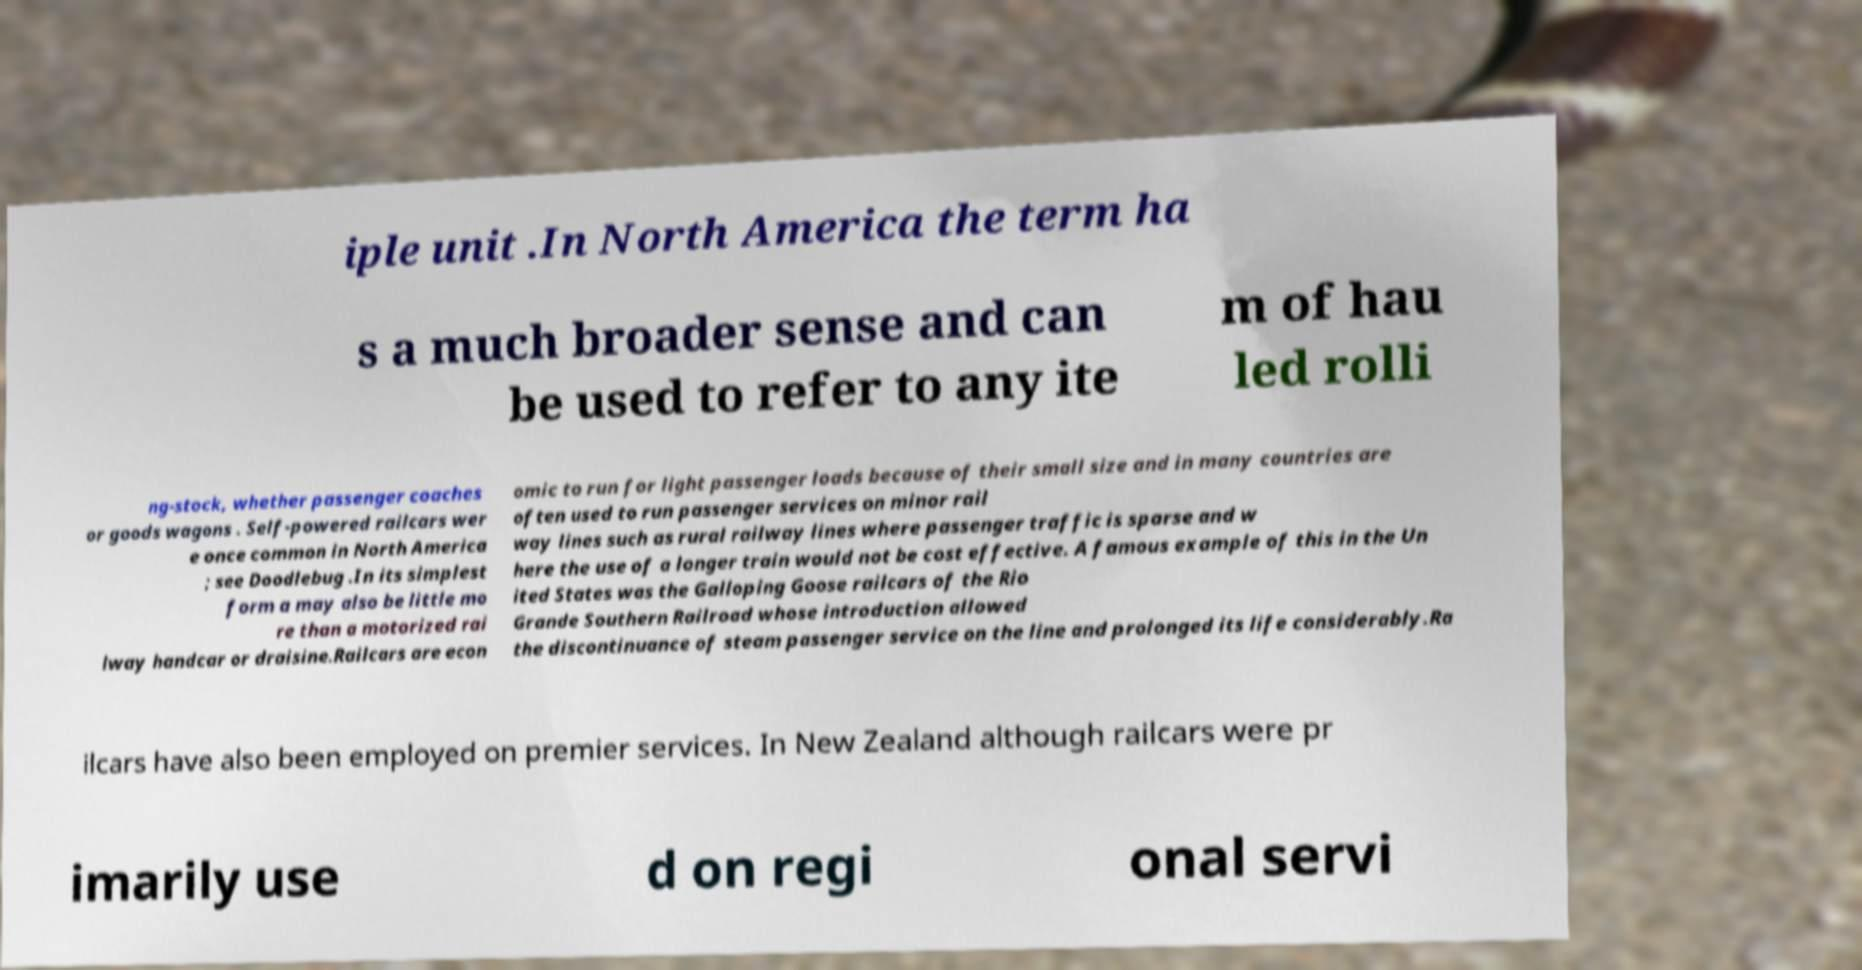There's text embedded in this image that I need extracted. Can you transcribe it verbatim? iple unit .In North America the term ha s a much broader sense and can be used to refer to any ite m of hau led rolli ng-stock, whether passenger coaches or goods wagons . Self-powered railcars wer e once common in North America ; see Doodlebug .In its simplest form a may also be little mo re than a motorized rai lway handcar or draisine.Railcars are econ omic to run for light passenger loads because of their small size and in many countries are often used to run passenger services on minor rail way lines such as rural railway lines where passenger traffic is sparse and w here the use of a longer train would not be cost effective. A famous example of this in the Un ited States was the Galloping Goose railcars of the Rio Grande Southern Railroad whose introduction allowed the discontinuance of steam passenger service on the line and prolonged its life considerably.Ra ilcars have also been employed on premier services. In New Zealand although railcars were pr imarily use d on regi onal servi 